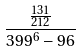<formula> <loc_0><loc_0><loc_500><loc_500>\frac { \frac { 1 3 1 } { 2 1 2 } } { 3 9 9 ^ { 6 } - 9 6 }</formula> 